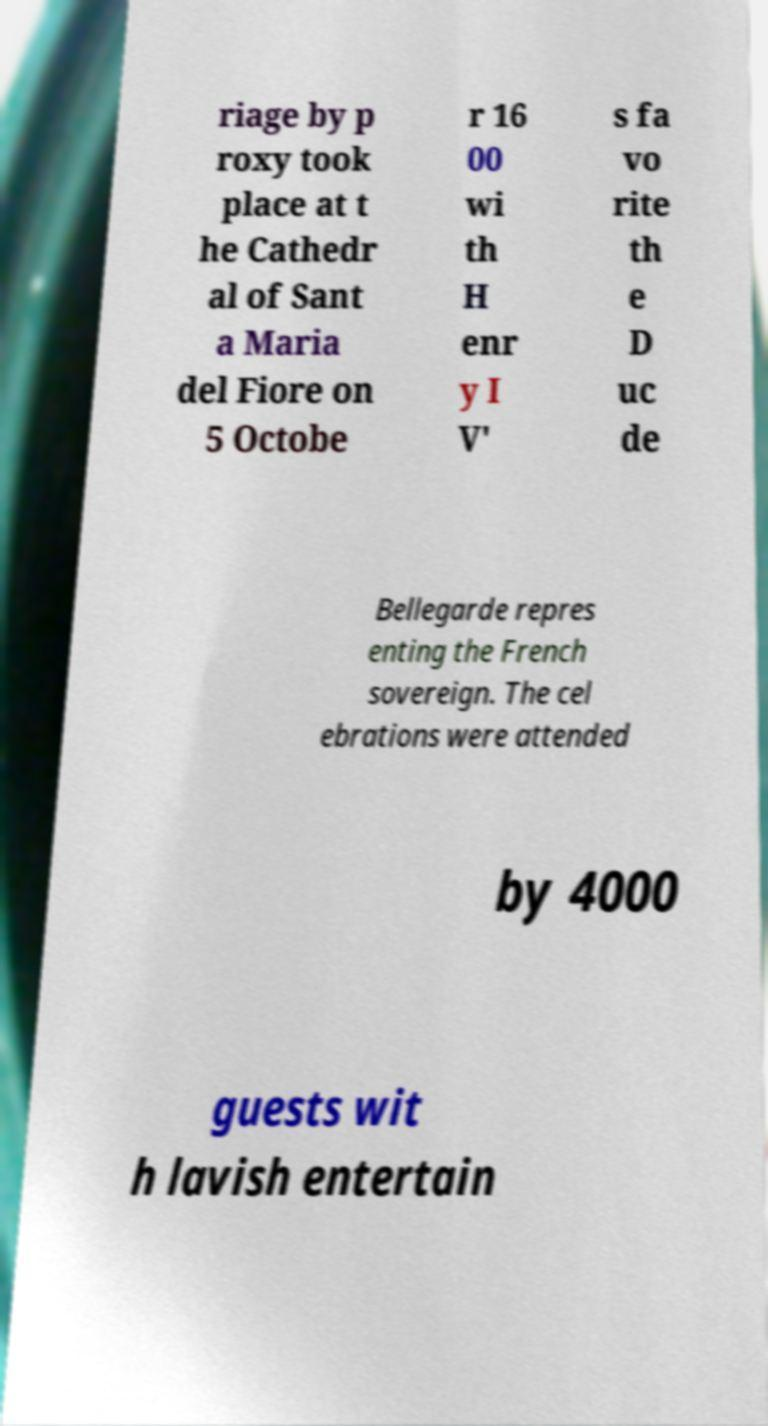There's text embedded in this image that I need extracted. Can you transcribe it verbatim? riage by p roxy took place at t he Cathedr al of Sant a Maria del Fiore on 5 Octobe r 16 00 wi th H enr y I V' s fa vo rite th e D uc de Bellegarde repres enting the French sovereign. The cel ebrations were attended by 4000 guests wit h lavish entertain 